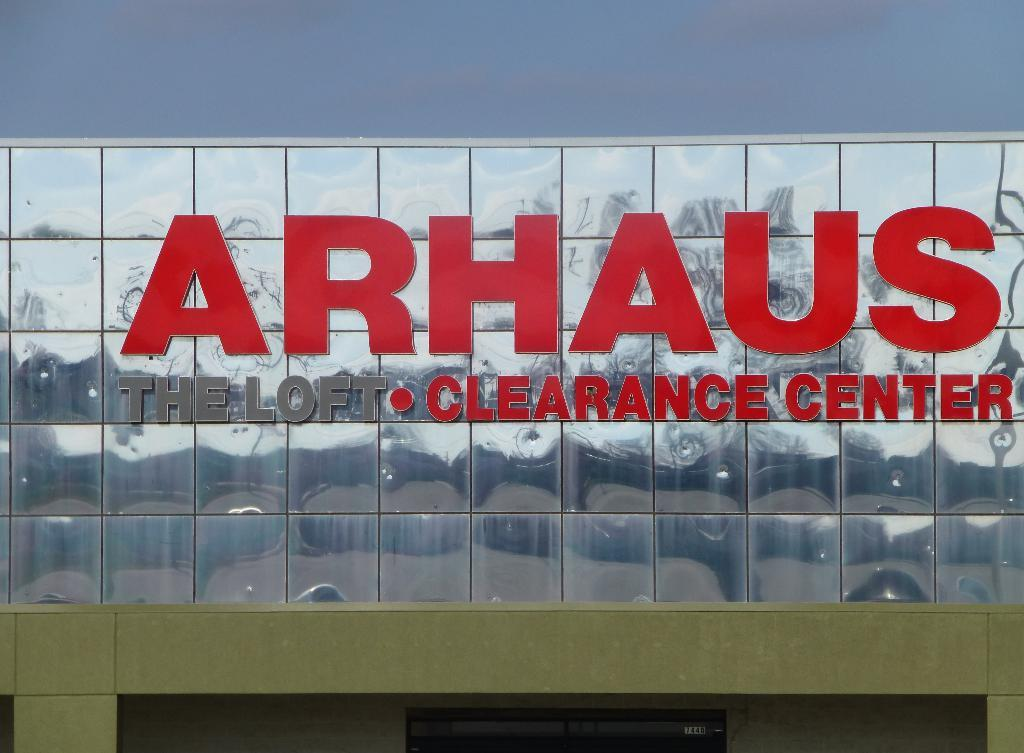<image>
Give a short and clear explanation of the subsequent image. a building that says 'arhaus the loft-clearance center' in front of it 